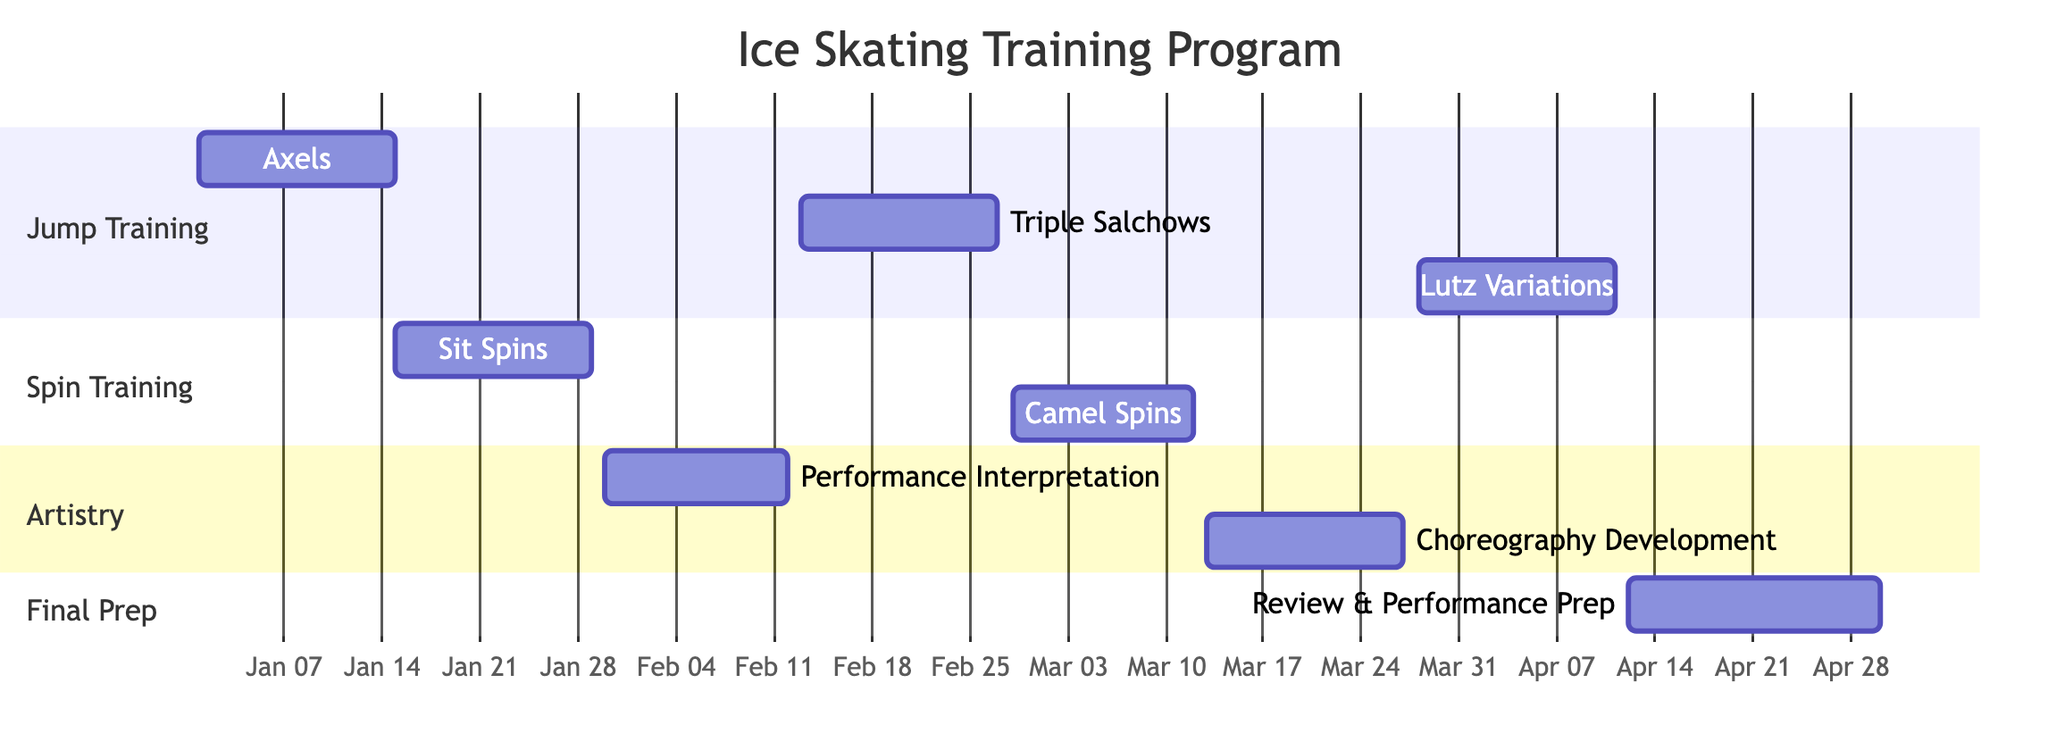What is the duration of the Jump Training - Axels task? The task "Jump Training - Axels" starts on January 1, 2024, and ends on January 15, 2024. The duration can be calculated as the difference between the end and start dates, which is 14 days.
Answer: 14 days How many Spin Training sessions are there? Looking at the diagram, there are two tasks under the "Spin Training" section: "Sit Spins" and "Camel Spins." Therefore, the total number of Spin Training sessions is two.
Answer: 2 Which task has the longest duration? When checking the durations of all tasks in the diagram, the "Review & Performance Prep" task lasts for 18 days, which is longer than all other tasks. Thus, it has the longest duration in the training program.
Answer: 18 days What is the end date for the Spin Training - Camel Spins task? The "Spin Training - Camel Spins" task starts on February 28, 2024, and has a duration of 13 days. Calculating the end date, we find it ends on March 12, 2024.
Answer: March 12, 2024 Which two tasks overlap in the timeline? By examining the timeline closely, the "Artistry - Performance Interpretation" task and the "Jump Training - Triple Salchows" task overlap. "Performance Interpretation" runs from January 30 to February 12, while "Triple Salchows" starts on February 13. The overlap is not direct, but spins and artistry tasks may have some overlap during training sessions due to concurrent skill development emphasis.
Answer: Artistry - Performance Interpretation and Jump Training - Triple Salchows What is the last task before the Final Review & Performance Prep? The "Jump Training - Lutz Variations" task, which occurs from March 28 to April 11, is the last task directly preceding "Final Review & Performance Prep" that starts on April 12, 2024.
Answer: Jump Training - Lutz Variations How many tasks focus on artistry? There are two tasks dedicated to artistry in the diagram: "Performance Interpretation" and "Choreography Development." Thus, the total number of artistry-focused tasks in the schedule is two.
Answer: 2 When does the training program start? The start date of the training program is clearly marked in the "Jump Training - Axels" task, which begins on January 1, 2024. Therefore, the training program starts on this date.
Answer: January 1, 2024 